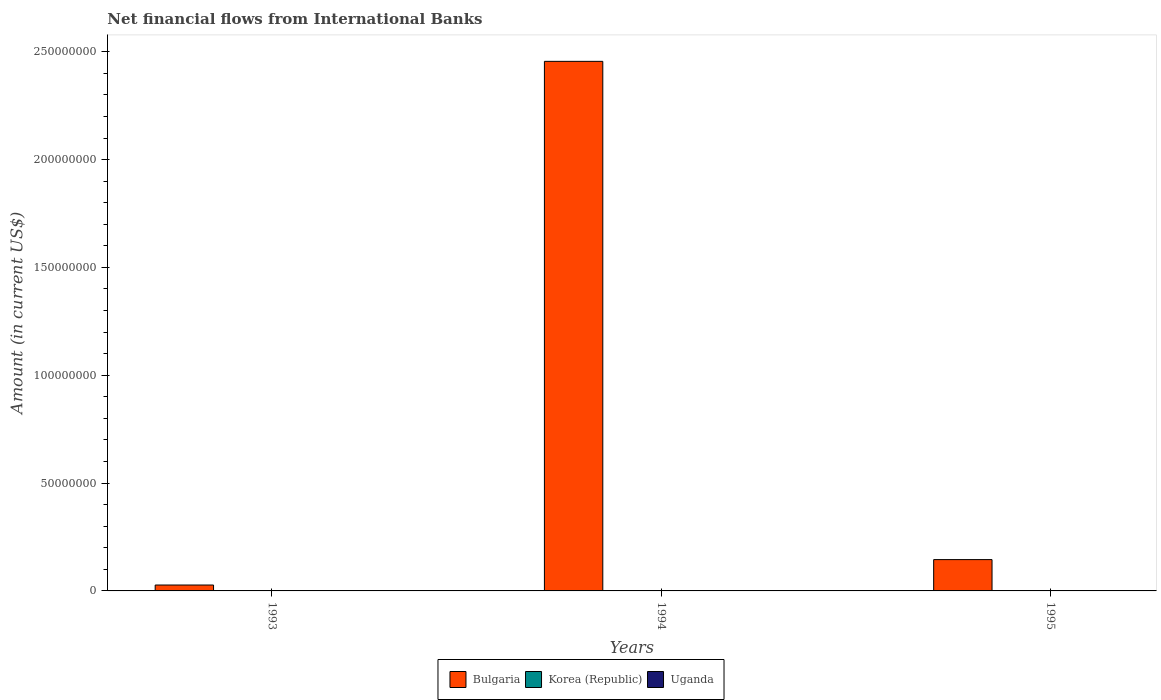Are the number of bars per tick equal to the number of legend labels?
Make the answer very short. No. Are the number of bars on each tick of the X-axis equal?
Your response must be concise. Yes. How many bars are there on the 1st tick from the right?
Your response must be concise. 1. In how many cases, is the number of bars for a given year not equal to the number of legend labels?
Keep it short and to the point. 3. What is the net financial aid flows in Korea (Republic) in 1994?
Provide a short and direct response. 0. Across all years, what is the maximum net financial aid flows in Bulgaria?
Keep it short and to the point. 2.46e+08. Across all years, what is the minimum net financial aid flows in Uganda?
Ensure brevity in your answer.  0. What is the difference between the net financial aid flows in Bulgaria in 1993 and that in 1994?
Give a very brief answer. -2.43e+08. What is the difference between the net financial aid flows in Korea (Republic) in 1993 and the net financial aid flows in Bulgaria in 1994?
Keep it short and to the point. -2.46e+08. In how many years, is the net financial aid flows in Bulgaria greater than 220000000 US$?
Provide a short and direct response. 1. What is the ratio of the net financial aid flows in Bulgaria in 1993 to that in 1995?
Provide a succinct answer. 0.19. Is the net financial aid flows in Bulgaria in 1993 less than that in 1995?
Make the answer very short. Yes. What is the difference between the highest and the second highest net financial aid flows in Bulgaria?
Your answer should be compact. 2.31e+08. What is the difference between the highest and the lowest net financial aid flows in Bulgaria?
Your answer should be compact. 2.43e+08. In how many years, is the net financial aid flows in Bulgaria greater than the average net financial aid flows in Bulgaria taken over all years?
Provide a short and direct response. 1. How many years are there in the graph?
Your answer should be very brief. 3. What is the difference between two consecutive major ticks on the Y-axis?
Ensure brevity in your answer.  5.00e+07. Are the values on the major ticks of Y-axis written in scientific E-notation?
Your response must be concise. No. Does the graph contain any zero values?
Offer a terse response. Yes. How many legend labels are there?
Your response must be concise. 3. What is the title of the graph?
Give a very brief answer. Net financial flows from International Banks. What is the label or title of the Y-axis?
Keep it short and to the point. Amount (in current US$). What is the Amount (in current US$) of Bulgaria in 1993?
Ensure brevity in your answer.  2.73e+06. What is the Amount (in current US$) of Bulgaria in 1994?
Provide a short and direct response. 2.46e+08. What is the Amount (in current US$) in Bulgaria in 1995?
Give a very brief answer. 1.45e+07. Across all years, what is the maximum Amount (in current US$) of Bulgaria?
Your answer should be very brief. 2.46e+08. Across all years, what is the minimum Amount (in current US$) in Bulgaria?
Provide a succinct answer. 2.73e+06. What is the total Amount (in current US$) in Bulgaria in the graph?
Your answer should be very brief. 2.63e+08. What is the total Amount (in current US$) in Uganda in the graph?
Your answer should be compact. 0. What is the difference between the Amount (in current US$) of Bulgaria in 1993 and that in 1994?
Provide a succinct answer. -2.43e+08. What is the difference between the Amount (in current US$) in Bulgaria in 1993 and that in 1995?
Your answer should be very brief. -1.18e+07. What is the difference between the Amount (in current US$) in Bulgaria in 1994 and that in 1995?
Your response must be concise. 2.31e+08. What is the average Amount (in current US$) in Bulgaria per year?
Your answer should be compact. 8.76e+07. What is the average Amount (in current US$) in Uganda per year?
Offer a very short reply. 0. What is the ratio of the Amount (in current US$) in Bulgaria in 1993 to that in 1994?
Your response must be concise. 0.01. What is the ratio of the Amount (in current US$) in Bulgaria in 1993 to that in 1995?
Your response must be concise. 0.19. What is the ratio of the Amount (in current US$) of Bulgaria in 1994 to that in 1995?
Your response must be concise. 16.9. What is the difference between the highest and the second highest Amount (in current US$) in Bulgaria?
Provide a short and direct response. 2.31e+08. What is the difference between the highest and the lowest Amount (in current US$) of Bulgaria?
Your answer should be compact. 2.43e+08. 